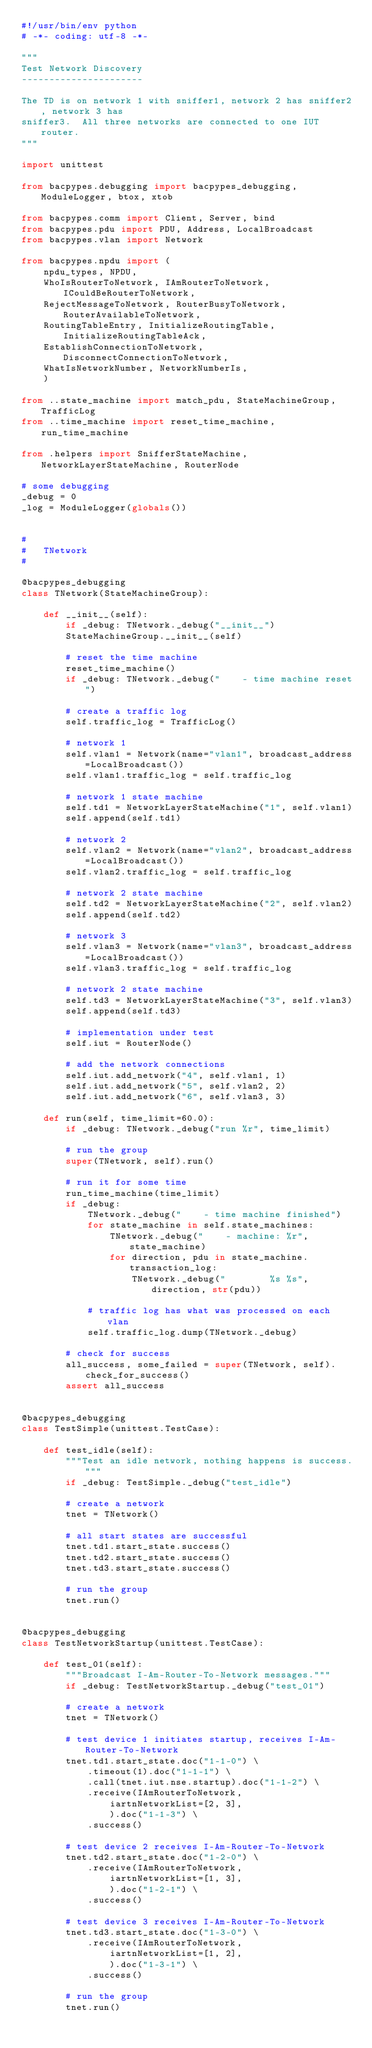Convert code to text. <code><loc_0><loc_0><loc_500><loc_500><_Python_>#!/usr/bin/env python
# -*- coding: utf-8 -*-

"""
Test Network Discovery
----------------------

The TD is on network 1 with sniffer1, network 2 has sniffer2, network 3 has
sniffer3.  All three networks are connected to one IUT router.
"""

import unittest

from bacpypes.debugging import bacpypes_debugging, ModuleLogger, btox, xtob

from bacpypes.comm import Client, Server, bind
from bacpypes.pdu import PDU, Address, LocalBroadcast
from bacpypes.vlan import Network

from bacpypes.npdu import (
    npdu_types, NPDU,
    WhoIsRouterToNetwork, IAmRouterToNetwork, ICouldBeRouterToNetwork,
    RejectMessageToNetwork, RouterBusyToNetwork, RouterAvailableToNetwork,
    RoutingTableEntry, InitializeRoutingTable, InitializeRoutingTableAck,
    EstablishConnectionToNetwork, DisconnectConnectionToNetwork,
    WhatIsNetworkNumber, NetworkNumberIs,
    )

from ..state_machine import match_pdu, StateMachineGroup, TrafficLog
from ..time_machine import reset_time_machine, run_time_machine

from .helpers import SnifferStateMachine, NetworkLayerStateMachine, RouterNode

# some debugging
_debug = 0
_log = ModuleLogger(globals())


#
#   TNetwork
#

@bacpypes_debugging
class TNetwork(StateMachineGroup):

    def __init__(self):
        if _debug: TNetwork._debug("__init__")
        StateMachineGroup.__init__(self)

        # reset the time machine
        reset_time_machine()
        if _debug: TNetwork._debug("    - time machine reset")

        # create a traffic log
        self.traffic_log = TrafficLog()

        # network 1
        self.vlan1 = Network(name="vlan1", broadcast_address=LocalBroadcast())
        self.vlan1.traffic_log = self.traffic_log

        # network 1 state machine
        self.td1 = NetworkLayerStateMachine("1", self.vlan1)
        self.append(self.td1)

        # network 2
        self.vlan2 = Network(name="vlan2", broadcast_address=LocalBroadcast())
        self.vlan2.traffic_log = self.traffic_log

        # network 2 state machine
        self.td2 = NetworkLayerStateMachine("2", self.vlan2)
        self.append(self.td2)

        # network 3
        self.vlan3 = Network(name="vlan3", broadcast_address=LocalBroadcast())
        self.vlan3.traffic_log = self.traffic_log

        # network 2 state machine
        self.td3 = NetworkLayerStateMachine("3", self.vlan3)
        self.append(self.td3)

        # implementation under test
        self.iut = RouterNode()

        # add the network connections
        self.iut.add_network("4", self.vlan1, 1)
        self.iut.add_network("5", self.vlan2, 2)
        self.iut.add_network("6", self.vlan3, 3)

    def run(self, time_limit=60.0):
        if _debug: TNetwork._debug("run %r", time_limit)

        # run the group
        super(TNetwork, self).run()

        # run it for some time
        run_time_machine(time_limit)
        if _debug:
            TNetwork._debug("    - time machine finished")
            for state_machine in self.state_machines:
                TNetwork._debug("    - machine: %r", state_machine)
                for direction, pdu in state_machine.transaction_log:
                    TNetwork._debug("        %s %s", direction, str(pdu))

            # traffic log has what was processed on each vlan
            self.traffic_log.dump(TNetwork._debug)

        # check for success
        all_success, some_failed = super(TNetwork, self).check_for_success()
        assert all_success


@bacpypes_debugging
class TestSimple(unittest.TestCase):

    def test_idle(self):
        """Test an idle network, nothing happens is success."""
        if _debug: TestSimple._debug("test_idle")

        # create a network
        tnet = TNetwork()

        # all start states are successful
        tnet.td1.start_state.success()
        tnet.td2.start_state.success()
        tnet.td3.start_state.success()

        # run the group
        tnet.run()


@bacpypes_debugging
class TestNetworkStartup(unittest.TestCase):

    def test_01(self):
        """Broadcast I-Am-Router-To-Network messages."""
        if _debug: TestNetworkStartup._debug("test_01")

        # create a network
        tnet = TNetwork()

        # test device 1 initiates startup, receives I-Am-Router-To-Network
        tnet.td1.start_state.doc("1-1-0") \
            .timeout(1).doc("1-1-1") \
            .call(tnet.iut.nse.startup).doc("1-1-2") \
            .receive(IAmRouterToNetwork,
                iartnNetworkList=[2, 3],
                ).doc("1-1-3") \
            .success()

        # test device 2 receives I-Am-Router-To-Network
        tnet.td2.start_state.doc("1-2-0") \
            .receive(IAmRouterToNetwork,
                iartnNetworkList=[1, 3],
                ).doc("1-2-1") \
            .success()

        # test device 3 receives I-Am-Router-To-Network
        tnet.td3.start_state.doc("1-3-0") \
            .receive(IAmRouterToNetwork,
                iartnNetworkList=[1, 2],
                ).doc("1-3-1") \
            .success()

        # run the group
        tnet.run()

</code> 